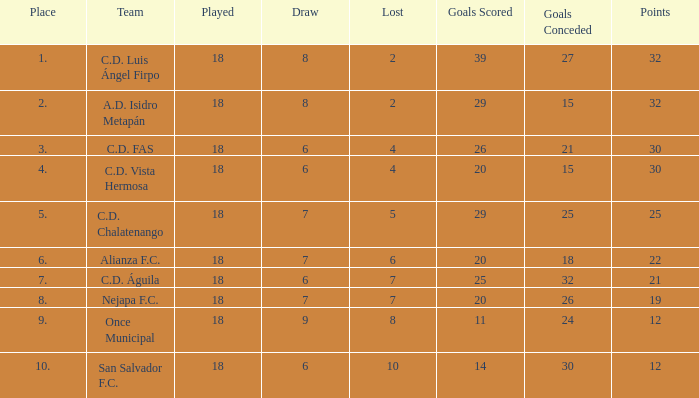What is the sum of draw with a lost smaller than 6, and a place of 5, and a goals scored less than 29? None. 